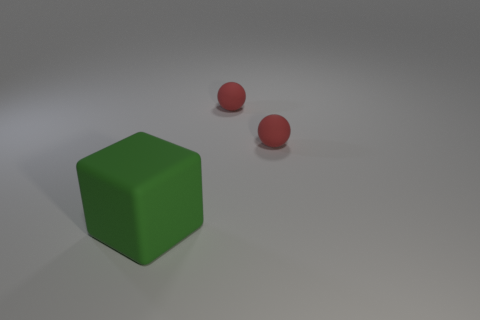Add 2 red rubber objects. How many objects exist? 5 Subtract all spheres. How many objects are left? 1 Add 2 big green matte cubes. How many big green matte cubes are left? 3 Add 1 green cubes. How many green cubes exist? 2 Subtract 0 purple cylinders. How many objects are left? 3 Subtract all small cyan matte blocks. Subtract all tiny red things. How many objects are left? 1 